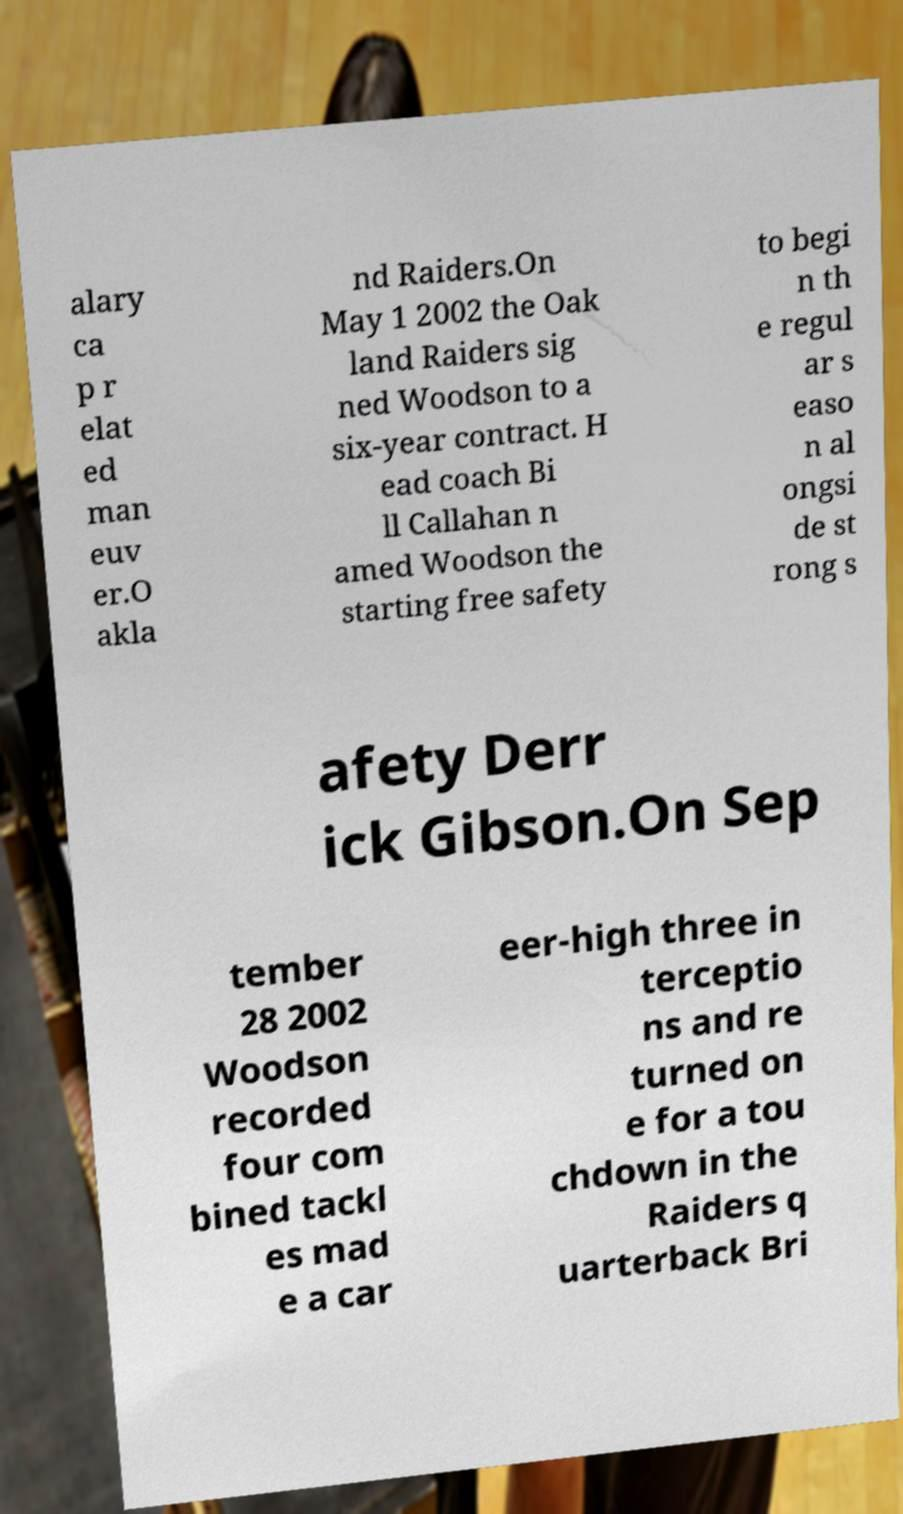Can you read and provide the text displayed in the image?This photo seems to have some interesting text. Can you extract and type it out for me? alary ca p r elat ed man euv er.O akla nd Raiders.On May 1 2002 the Oak land Raiders sig ned Woodson to a six-year contract. H ead coach Bi ll Callahan n amed Woodson the starting free safety to begi n th e regul ar s easo n al ongsi de st rong s afety Derr ick Gibson.On Sep tember 28 2002 Woodson recorded four com bined tackl es mad e a car eer-high three in terceptio ns and re turned on e for a tou chdown in the Raiders q uarterback Bri 